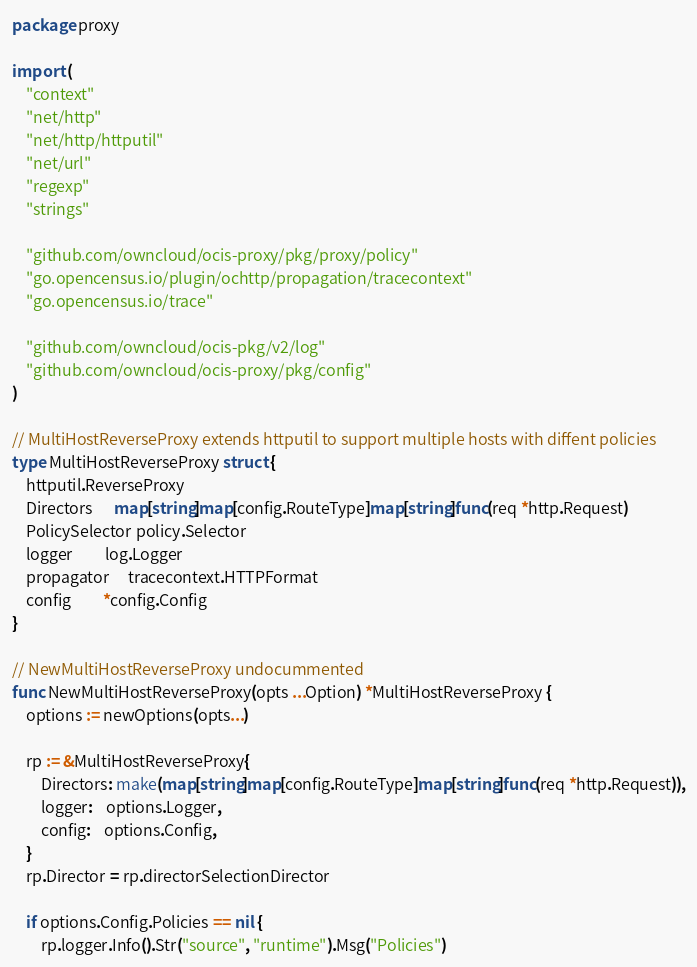<code> <loc_0><loc_0><loc_500><loc_500><_Go_>package proxy

import (
	"context"
	"net/http"
	"net/http/httputil"
	"net/url"
	"regexp"
	"strings"

	"github.com/owncloud/ocis-proxy/pkg/proxy/policy"
	"go.opencensus.io/plugin/ochttp/propagation/tracecontext"
	"go.opencensus.io/trace"

	"github.com/owncloud/ocis-pkg/v2/log"
	"github.com/owncloud/ocis-proxy/pkg/config"
)

// MultiHostReverseProxy extends httputil to support multiple hosts with diffent policies
type MultiHostReverseProxy struct {
	httputil.ReverseProxy
	Directors      map[string]map[config.RouteType]map[string]func(req *http.Request)
	PolicySelector policy.Selector
	logger         log.Logger
	propagator     tracecontext.HTTPFormat
	config         *config.Config
}

// NewMultiHostReverseProxy undocummented
func NewMultiHostReverseProxy(opts ...Option) *MultiHostReverseProxy {
	options := newOptions(opts...)

	rp := &MultiHostReverseProxy{
		Directors: make(map[string]map[config.RouteType]map[string]func(req *http.Request)),
		logger:    options.Logger,
		config:    options.Config,
	}
	rp.Director = rp.directorSelectionDirector

	if options.Config.Policies == nil {
		rp.logger.Info().Str("source", "runtime").Msg("Policies")</code> 